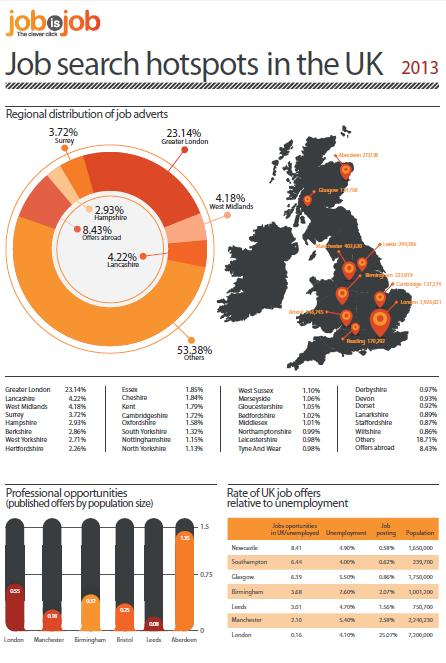Identify some key points in this picture. In 2013, only 4.18% of job advertisements in the West Midlands reflected the targeted demographic. The county in England that had the highest percentage of job adverts in 2013 was Greater London. In 2013, Lancashire had the second highest percentage of job adverts in England. In 2013, the percentage of job advertisements in Surrey was 3.72%. 